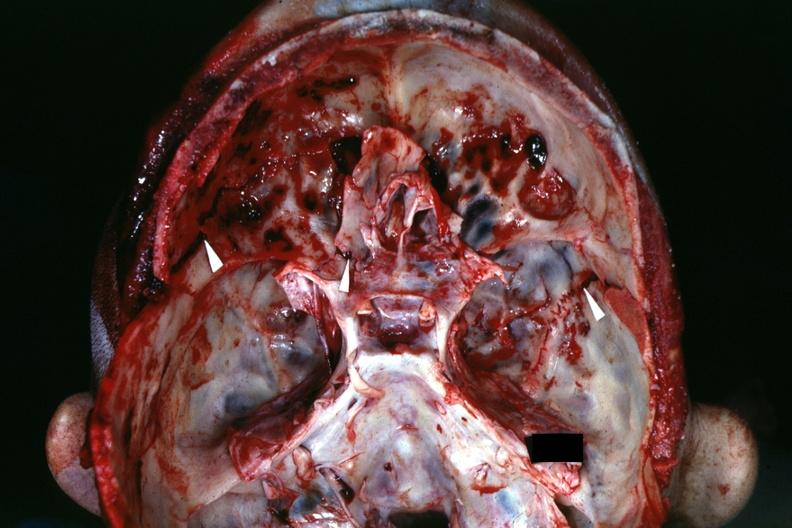what is present?
Answer the question using a single word or phrase. Bone 